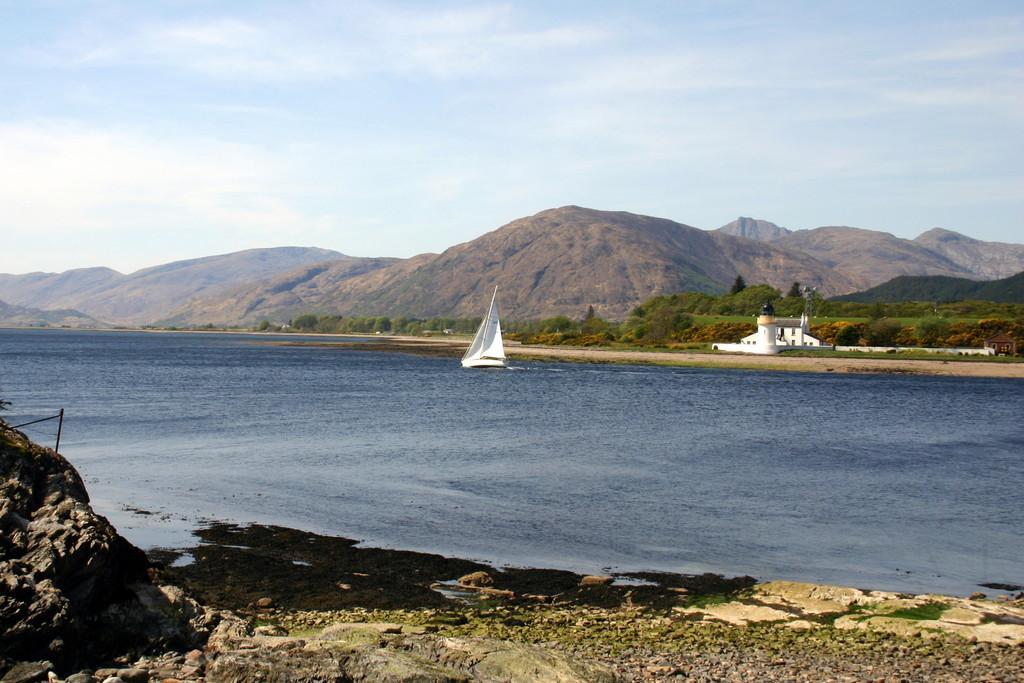How would you summarize this image in a sentence or two? In this image, we can see water, there is a white color boat on the water, there are some green color trees, we can see some mountains, at the top there is a sky. 